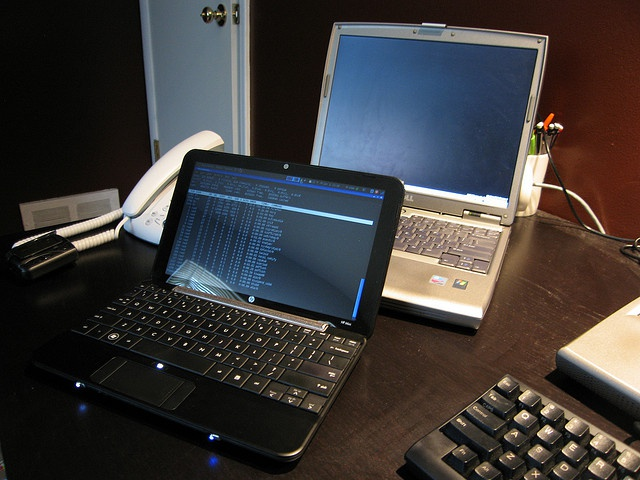Describe the objects in this image and their specific colors. I can see laptop in black, blue, navy, and gray tones, laptop in black, navy, blue, gray, and darkgray tones, keyboard in black and gray tones, keyboard in black and gray tones, and keyboard in black, gray, darkgray, and tan tones in this image. 